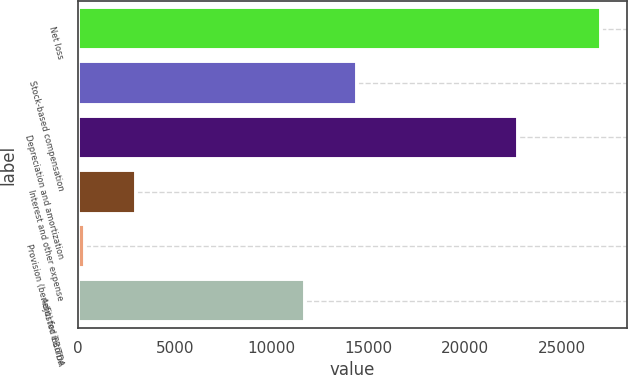Convert chart to OTSL. <chart><loc_0><loc_0><loc_500><loc_500><bar_chart><fcel>Net loss<fcel>Stock-based compensation<fcel>Depreciation and amortization<fcel>Interest and other expense<fcel>Provision (benefit) for income<fcel>Adjusted EBITDA<nl><fcel>27026<fcel>14411.9<fcel>22730<fcel>3023.9<fcel>357<fcel>11745<nl></chart> 